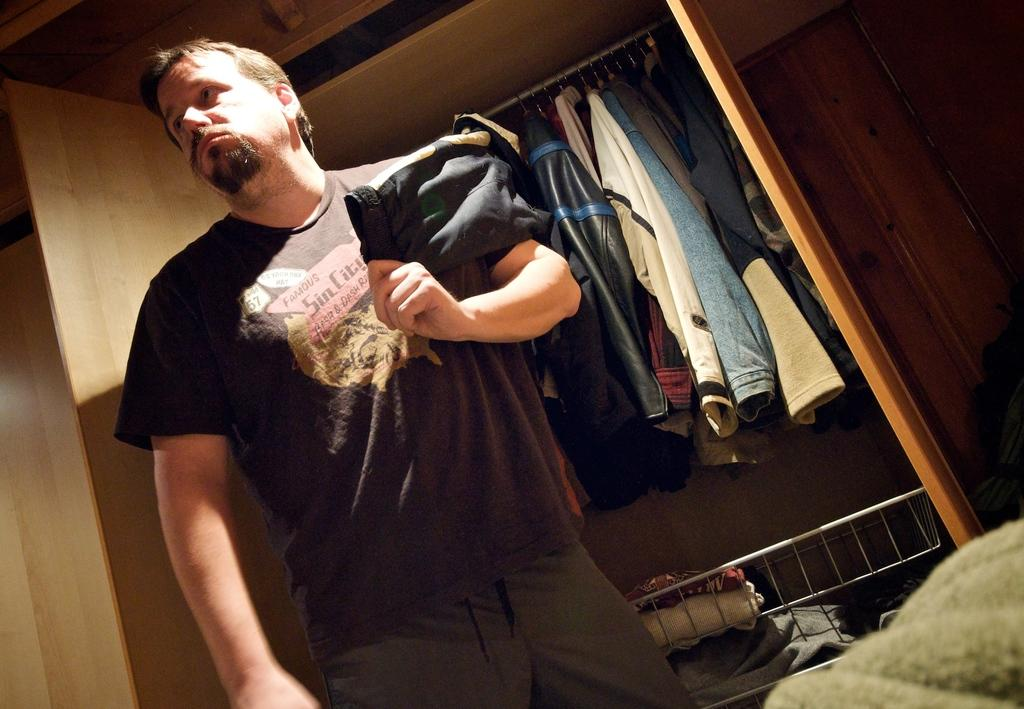Who is the main subject in the image? There is a person in the center of the image. What is the person holding in the image? The person is holding clothes. What can be seen in the background of the image? There are clothes placed in a cupboard in the background of the image. Can you tell me how many cacti are in the image? There are no cacti present in the image. What type of snail can be seen crawling on the person's clothes in the image? There is no snail present in the image; the person is holding clothes. 